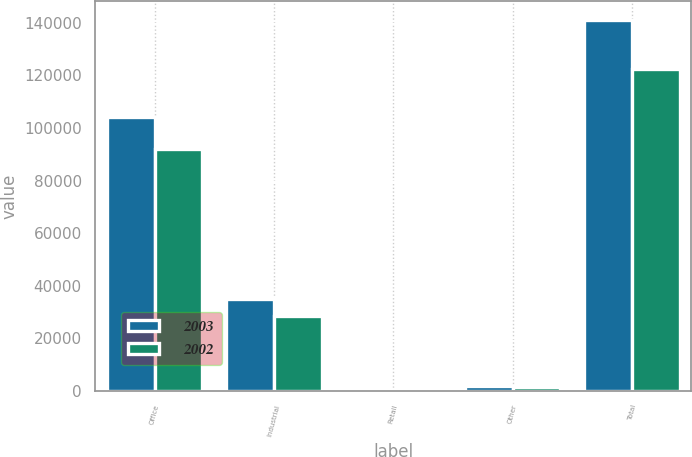Convert chart. <chart><loc_0><loc_0><loc_500><loc_500><stacked_bar_chart><ecel><fcel>Office<fcel>Industrial<fcel>Retail<fcel>Other<fcel>Total<nl><fcel>2003<fcel>104056<fcel>34872<fcel>609<fcel>1689<fcel>141226<nl><fcel>2002<fcel>92190<fcel>28585<fcel>281<fcel>1394<fcel>122450<nl></chart> 